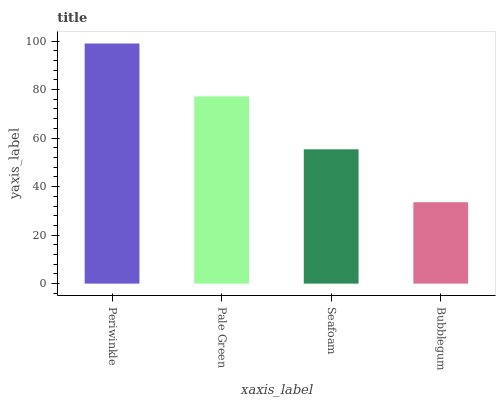Is Pale Green the minimum?
Answer yes or no. No. Is Pale Green the maximum?
Answer yes or no. No. Is Periwinkle greater than Pale Green?
Answer yes or no. Yes. Is Pale Green less than Periwinkle?
Answer yes or no. Yes. Is Pale Green greater than Periwinkle?
Answer yes or no. No. Is Periwinkle less than Pale Green?
Answer yes or no. No. Is Pale Green the high median?
Answer yes or no. Yes. Is Seafoam the low median?
Answer yes or no. Yes. Is Seafoam the high median?
Answer yes or no. No. Is Pale Green the low median?
Answer yes or no. No. 